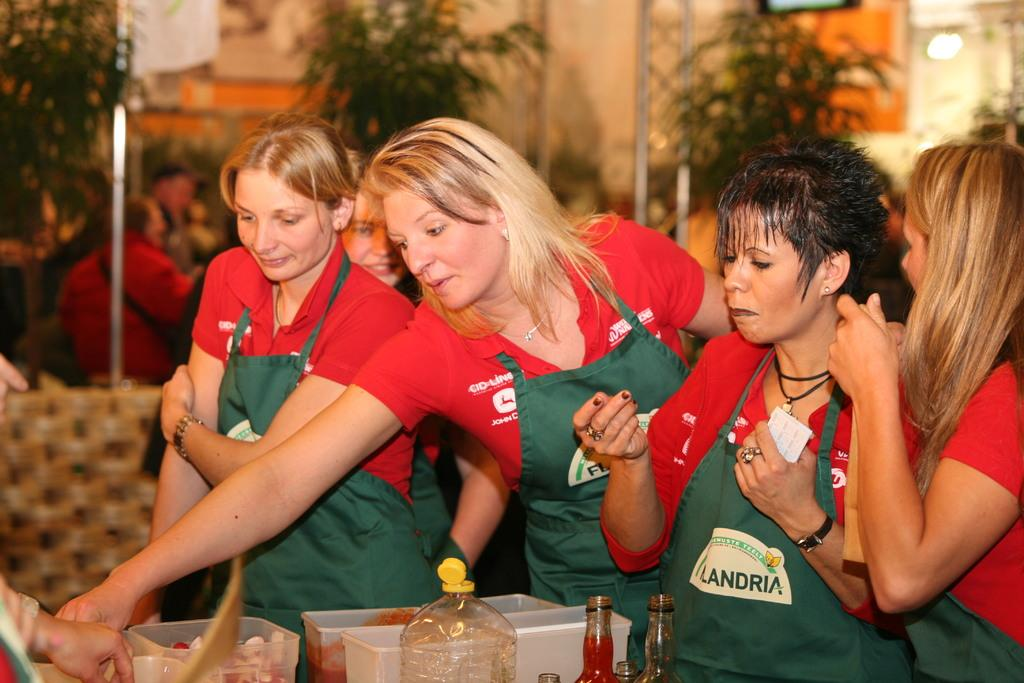Who is present in the image? There are women in the image. What are the women doing in the image? The women are standing at a table. What can be seen on the table? There are items on the table. What is the purpose of the women standing at the table? The women are trying to prepare something. What type of cast can be seen on the arm of one of the women in the image? There is no cast visible on any of the women's arms in the image. 